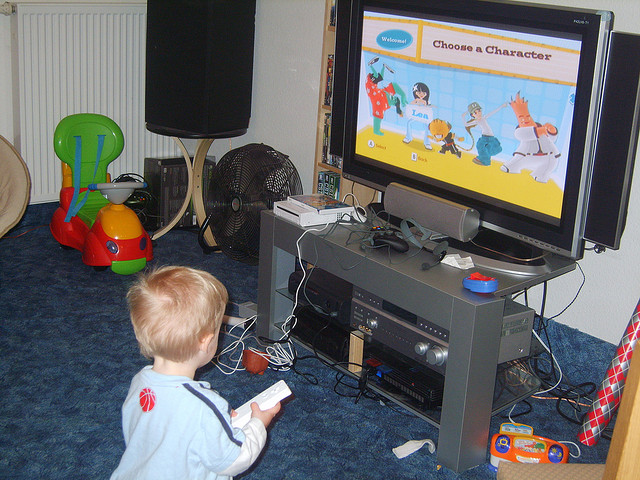Identify and read out the text in this image. Choose A Character 